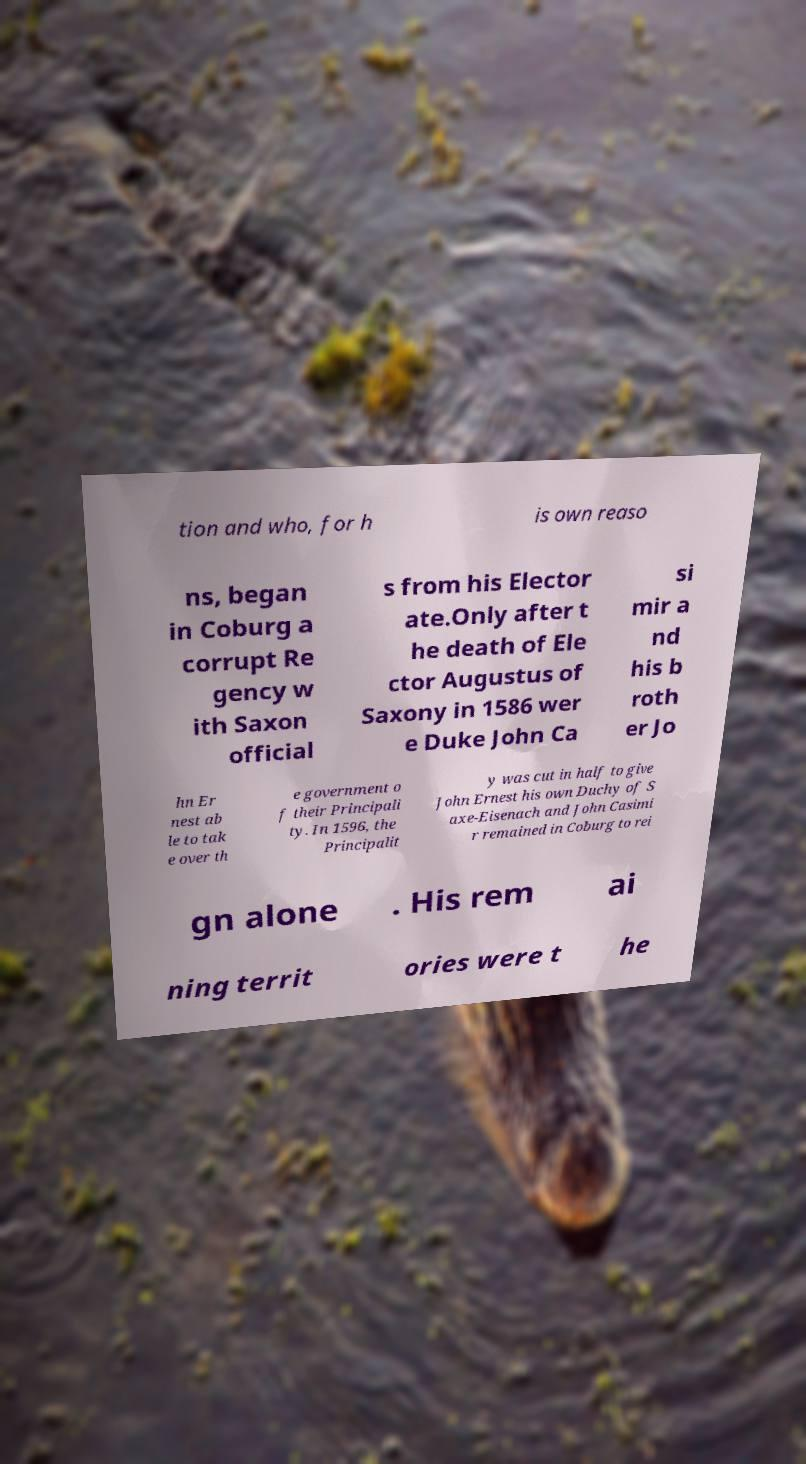Can you read and provide the text displayed in the image?This photo seems to have some interesting text. Can you extract and type it out for me? tion and who, for h is own reaso ns, began in Coburg a corrupt Re gency w ith Saxon official s from his Elector ate.Only after t he death of Ele ctor Augustus of Saxony in 1586 wer e Duke John Ca si mir a nd his b roth er Jo hn Er nest ab le to tak e over th e government o f their Principali ty. In 1596, the Principalit y was cut in half to give John Ernest his own Duchy of S axe-Eisenach and John Casimi r remained in Coburg to rei gn alone . His rem ai ning territ ories were t he 